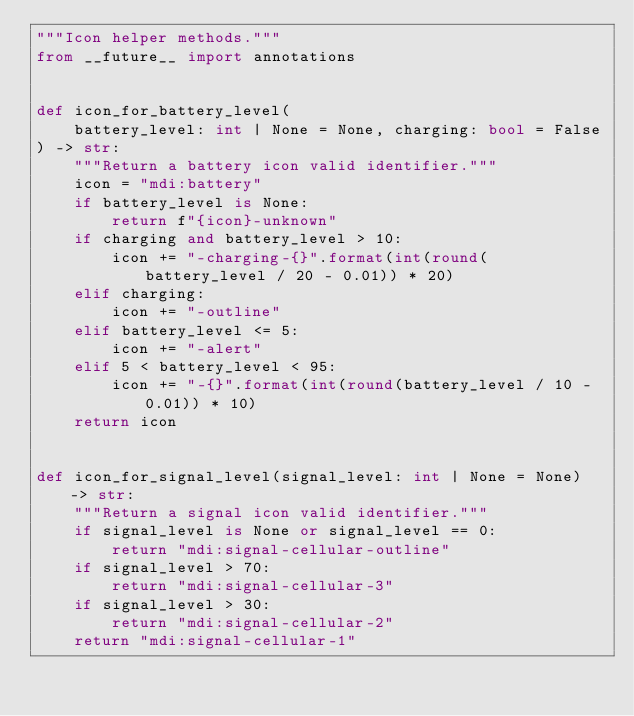Convert code to text. <code><loc_0><loc_0><loc_500><loc_500><_Python_>"""Icon helper methods."""
from __future__ import annotations


def icon_for_battery_level(
    battery_level: int | None = None, charging: bool = False
) -> str:
    """Return a battery icon valid identifier."""
    icon = "mdi:battery"
    if battery_level is None:
        return f"{icon}-unknown"
    if charging and battery_level > 10:
        icon += "-charging-{}".format(int(round(battery_level / 20 - 0.01)) * 20)
    elif charging:
        icon += "-outline"
    elif battery_level <= 5:
        icon += "-alert"
    elif 5 < battery_level < 95:
        icon += "-{}".format(int(round(battery_level / 10 - 0.01)) * 10)
    return icon


def icon_for_signal_level(signal_level: int | None = None) -> str:
    """Return a signal icon valid identifier."""
    if signal_level is None or signal_level == 0:
        return "mdi:signal-cellular-outline"
    if signal_level > 70:
        return "mdi:signal-cellular-3"
    if signal_level > 30:
        return "mdi:signal-cellular-2"
    return "mdi:signal-cellular-1"
</code> 